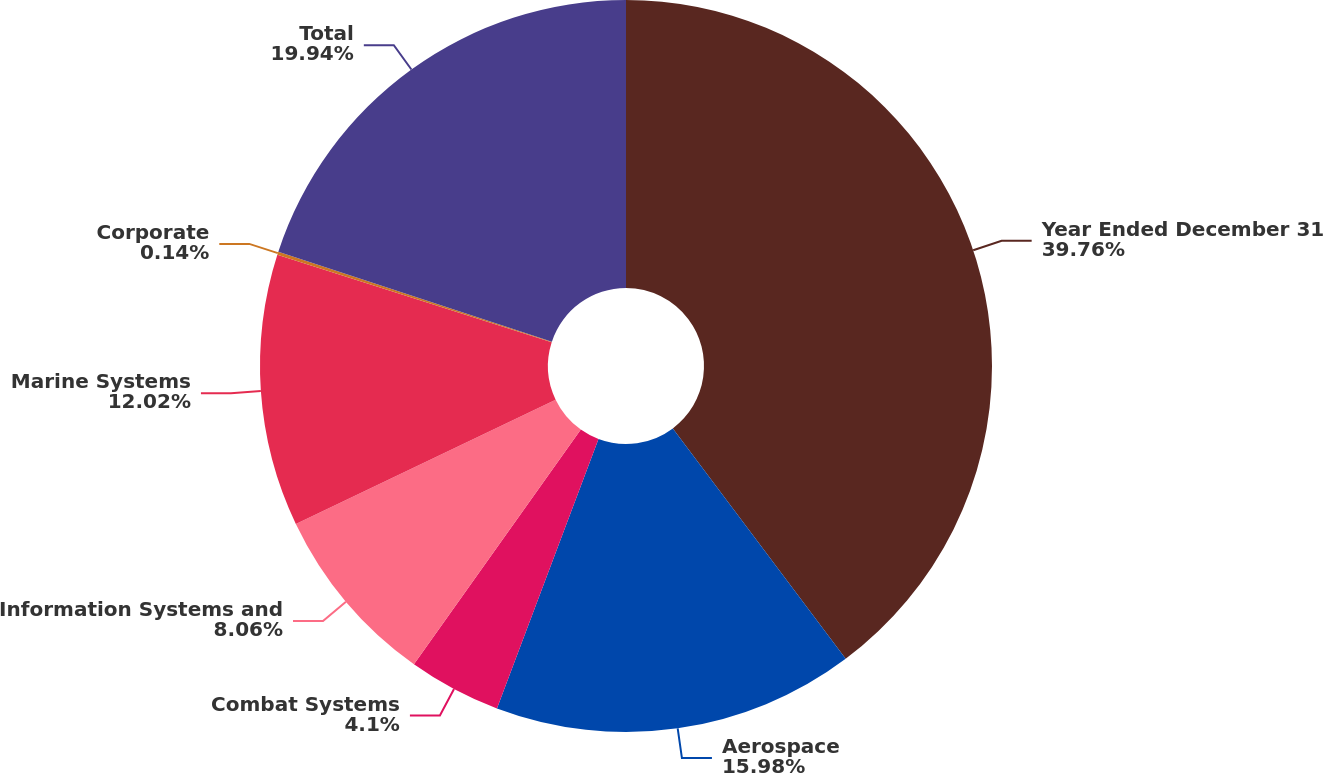Convert chart to OTSL. <chart><loc_0><loc_0><loc_500><loc_500><pie_chart><fcel>Year Ended December 31<fcel>Aerospace<fcel>Combat Systems<fcel>Information Systems and<fcel>Marine Systems<fcel>Corporate<fcel>Total<nl><fcel>39.75%<fcel>15.98%<fcel>4.1%<fcel>8.06%<fcel>12.02%<fcel>0.14%<fcel>19.94%<nl></chart> 